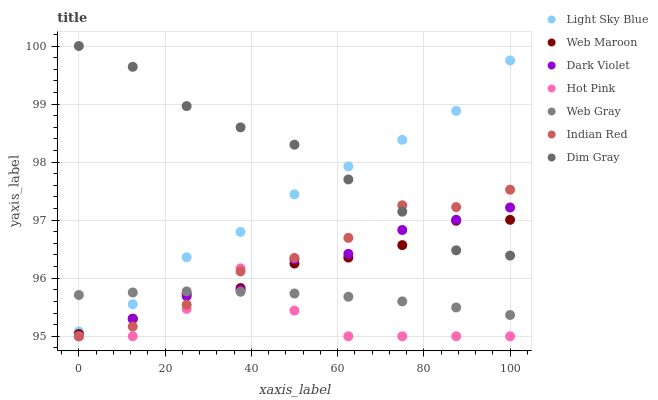Does Hot Pink have the minimum area under the curve?
Answer yes or no. Yes. Does Dim Gray have the maximum area under the curve?
Answer yes or no. Yes. Does Dim Gray have the minimum area under the curve?
Answer yes or no. No. Does Hot Pink have the maximum area under the curve?
Answer yes or no. No. Is Web Gray the smoothest?
Answer yes or no. Yes. Is Hot Pink the roughest?
Answer yes or no. Yes. Is Dim Gray the smoothest?
Answer yes or no. No. Is Dim Gray the roughest?
Answer yes or no. No. Does Hot Pink have the lowest value?
Answer yes or no. Yes. Does Dim Gray have the lowest value?
Answer yes or no. No. Does Dim Gray have the highest value?
Answer yes or no. Yes. Does Hot Pink have the highest value?
Answer yes or no. No. Is Dark Violet less than Light Sky Blue?
Answer yes or no. Yes. Is Dim Gray greater than Web Gray?
Answer yes or no. Yes. Does Web Gray intersect Indian Red?
Answer yes or no. Yes. Is Web Gray less than Indian Red?
Answer yes or no. No. Is Web Gray greater than Indian Red?
Answer yes or no. No. Does Dark Violet intersect Light Sky Blue?
Answer yes or no. No. 